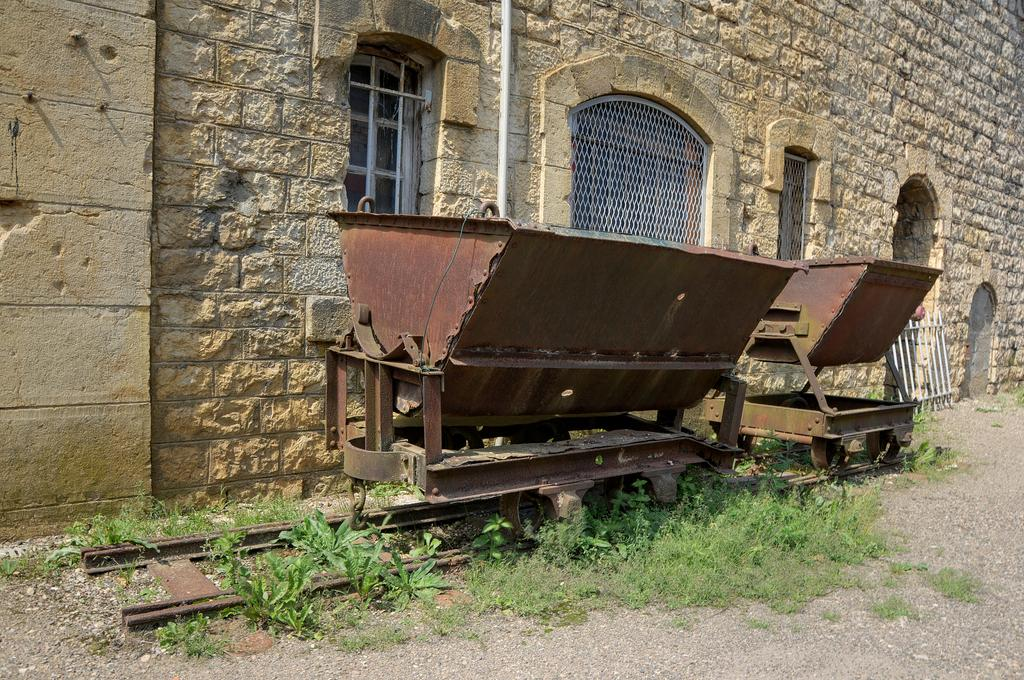What is located in the center of the image? There are trolleys in the center of the image. What type of surface is visible beneath the trolleys? There is grass on the ground in the image. What can be seen in the background of the image? There is a wall and windows in the background of the image. What type of plantation is visible in the image? There is no plantation present in the image. What cord is connected to the trolleys in the image? There is no cord connected to the trolleys in the image. 